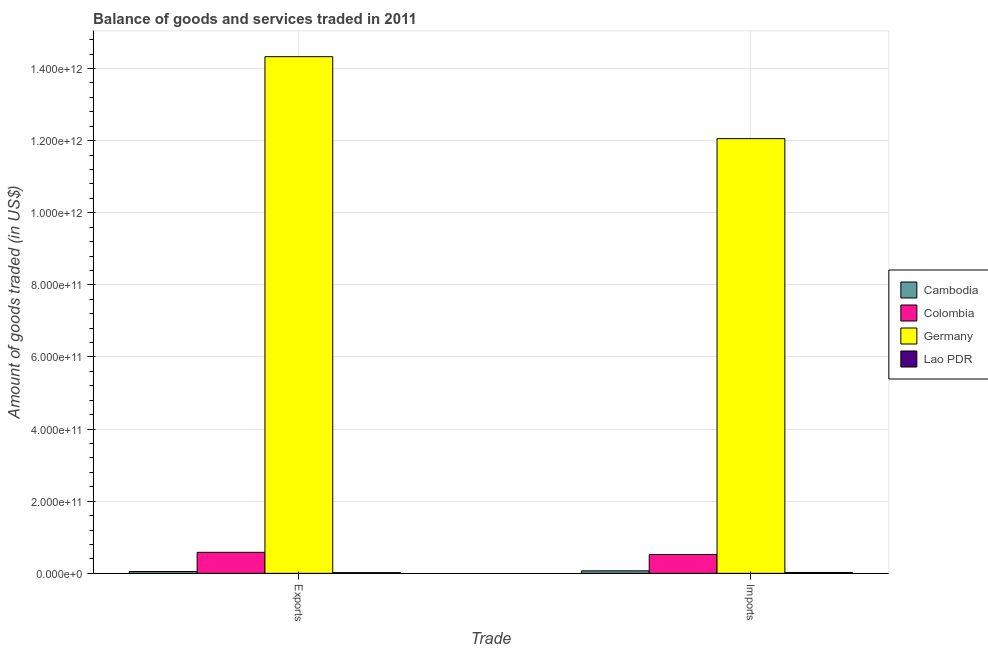How many groups of bars are there?
Give a very brief answer. 2. Are the number of bars per tick equal to the number of legend labels?
Ensure brevity in your answer.  Yes. How many bars are there on the 2nd tick from the left?
Give a very brief answer. 4. What is the label of the 1st group of bars from the left?
Provide a succinct answer. Exports. What is the amount of goods imported in Lao PDR?
Your response must be concise. 2.42e+09. Across all countries, what is the maximum amount of goods imported?
Provide a short and direct response. 1.21e+12. Across all countries, what is the minimum amount of goods exported?
Make the answer very short. 1.85e+09. In which country was the amount of goods exported maximum?
Your response must be concise. Germany. In which country was the amount of goods exported minimum?
Keep it short and to the point. Lao PDR. What is the total amount of goods exported in the graph?
Offer a terse response. 1.50e+12. What is the difference between the amount of goods imported in Germany and that in Colombia?
Give a very brief answer. 1.15e+12. What is the difference between the amount of goods exported in Germany and the amount of goods imported in Colombia?
Give a very brief answer. 1.38e+12. What is the average amount of goods exported per country?
Provide a succinct answer. 3.75e+11. What is the difference between the amount of goods imported and amount of goods exported in Lao PDR?
Your response must be concise. 5.69e+08. What is the ratio of the amount of goods exported in Colombia to that in Germany?
Offer a terse response. 0.04. Is the amount of goods imported in Lao PDR less than that in Colombia?
Make the answer very short. Yes. In how many countries, is the amount of goods imported greater than the average amount of goods imported taken over all countries?
Keep it short and to the point. 1. What does the 3rd bar from the left in Imports represents?
Offer a very short reply. Germany. How many bars are there?
Your answer should be compact. 8. How many countries are there in the graph?
Give a very brief answer. 4. What is the difference between two consecutive major ticks on the Y-axis?
Keep it short and to the point. 2.00e+11. Does the graph contain any zero values?
Offer a terse response. No. Where does the legend appear in the graph?
Provide a succinct answer. Center right. How are the legend labels stacked?
Provide a short and direct response. Vertical. What is the title of the graph?
Offer a very short reply. Balance of goods and services traded in 2011. What is the label or title of the X-axis?
Your answer should be very brief. Trade. What is the label or title of the Y-axis?
Make the answer very short. Amount of goods traded (in US$). What is the Amount of goods traded (in US$) in Cambodia in Exports?
Offer a very short reply. 5.03e+09. What is the Amount of goods traded (in US$) in Colombia in Exports?
Provide a short and direct response. 5.83e+1. What is the Amount of goods traded (in US$) of Germany in Exports?
Give a very brief answer. 1.43e+12. What is the Amount of goods traded (in US$) in Lao PDR in Exports?
Your answer should be very brief. 1.85e+09. What is the Amount of goods traded (in US$) of Cambodia in Imports?
Your answer should be very brief. 6.94e+09. What is the Amount of goods traded (in US$) in Colombia in Imports?
Your answer should be very brief. 5.21e+1. What is the Amount of goods traded (in US$) of Germany in Imports?
Make the answer very short. 1.21e+12. What is the Amount of goods traded (in US$) in Lao PDR in Imports?
Provide a short and direct response. 2.42e+09. Across all Trade, what is the maximum Amount of goods traded (in US$) of Cambodia?
Your answer should be very brief. 6.94e+09. Across all Trade, what is the maximum Amount of goods traded (in US$) of Colombia?
Your response must be concise. 5.83e+1. Across all Trade, what is the maximum Amount of goods traded (in US$) of Germany?
Offer a terse response. 1.43e+12. Across all Trade, what is the maximum Amount of goods traded (in US$) in Lao PDR?
Provide a succinct answer. 2.42e+09. Across all Trade, what is the minimum Amount of goods traded (in US$) of Cambodia?
Keep it short and to the point. 5.03e+09. Across all Trade, what is the minimum Amount of goods traded (in US$) in Colombia?
Give a very brief answer. 5.21e+1. Across all Trade, what is the minimum Amount of goods traded (in US$) of Germany?
Provide a short and direct response. 1.21e+12. Across all Trade, what is the minimum Amount of goods traded (in US$) in Lao PDR?
Make the answer very short. 1.85e+09. What is the total Amount of goods traded (in US$) of Cambodia in the graph?
Give a very brief answer. 1.20e+1. What is the total Amount of goods traded (in US$) of Colombia in the graph?
Give a very brief answer. 1.10e+11. What is the total Amount of goods traded (in US$) in Germany in the graph?
Your answer should be very brief. 2.64e+12. What is the total Amount of goods traded (in US$) of Lao PDR in the graph?
Make the answer very short. 4.28e+09. What is the difference between the Amount of goods traded (in US$) in Cambodia in Exports and that in Imports?
Offer a very short reply. -1.90e+09. What is the difference between the Amount of goods traded (in US$) of Colombia in Exports and that in Imports?
Offer a terse response. 6.14e+09. What is the difference between the Amount of goods traded (in US$) in Germany in Exports and that in Imports?
Provide a succinct answer. 2.27e+11. What is the difference between the Amount of goods traded (in US$) in Lao PDR in Exports and that in Imports?
Keep it short and to the point. -5.69e+08. What is the difference between the Amount of goods traded (in US$) in Cambodia in Exports and the Amount of goods traded (in US$) in Colombia in Imports?
Ensure brevity in your answer.  -4.71e+1. What is the difference between the Amount of goods traded (in US$) in Cambodia in Exports and the Amount of goods traded (in US$) in Germany in Imports?
Make the answer very short. -1.20e+12. What is the difference between the Amount of goods traded (in US$) in Cambodia in Exports and the Amount of goods traded (in US$) in Lao PDR in Imports?
Ensure brevity in your answer.  2.61e+09. What is the difference between the Amount of goods traded (in US$) of Colombia in Exports and the Amount of goods traded (in US$) of Germany in Imports?
Make the answer very short. -1.15e+12. What is the difference between the Amount of goods traded (in US$) of Colombia in Exports and the Amount of goods traded (in US$) of Lao PDR in Imports?
Keep it short and to the point. 5.58e+1. What is the difference between the Amount of goods traded (in US$) in Germany in Exports and the Amount of goods traded (in US$) in Lao PDR in Imports?
Provide a short and direct response. 1.43e+12. What is the average Amount of goods traded (in US$) in Cambodia per Trade?
Offer a terse response. 5.99e+09. What is the average Amount of goods traded (in US$) in Colombia per Trade?
Make the answer very short. 5.52e+1. What is the average Amount of goods traded (in US$) in Germany per Trade?
Provide a short and direct response. 1.32e+12. What is the average Amount of goods traded (in US$) of Lao PDR per Trade?
Give a very brief answer. 2.14e+09. What is the difference between the Amount of goods traded (in US$) in Cambodia and Amount of goods traded (in US$) in Colombia in Exports?
Give a very brief answer. -5.32e+1. What is the difference between the Amount of goods traded (in US$) of Cambodia and Amount of goods traded (in US$) of Germany in Exports?
Make the answer very short. -1.43e+12. What is the difference between the Amount of goods traded (in US$) of Cambodia and Amount of goods traded (in US$) of Lao PDR in Exports?
Offer a terse response. 3.18e+09. What is the difference between the Amount of goods traded (in US$) of Colombia and Amount of goods traded (in US$) of Germany in Exports?
Give a very brief answer. -1.37e+12. What is the difference between the Amount of goods traded (in US$) in Colombia and Amount of goods traded (in US$) in Lao PDR in Exports?
Make the answer very short. 5.64e+1. What is the difference between the Amount of goods traded (in US$) of Germany and Amount of goods traded (in US$) of Lao PDR in Exports?
Your response must be concise. 1.43e+12. What is the difference between the Amount of goods traded (in US$) in Cambodia and Amount of goods traded (in US$) in Colombia in Imports?
Offer a terse response. -4.52e+1. What is the difference between the Amount of goods traded (in US$) in Cambodia and Amount of goods traded (in US$) in Germany in Imports?
Offer a very short reply. -1.20e+12. What is the difference between the Amount of goods traded (in US$) in Cambodia and Amount of goods traded (in US$) in Lao PDR in Imports?
Provide a short and direct response. 4.51e+09. What is the difference between the Amount of goods traded (in US$) in Colombia and Amount of goods traded (in US$) in Germany in Imports?
Offer a terse response. -1.15e+12. What is the difference between the Amount of goods traded (in US$) of Colombia and Amount of goods traded (in US$) of Lao PDR in Imports?
Provide a succinct answer. 4.97e+1. What is the difference between the Amount of goods traded (in US$) of Germany and Amount of goods traded (in US$) of Lao PDR in Imports?
Offer a terse response. 1.20e+12. What is the ratio of the Amount of goods traded (in US$) in Cambodia in Exports to that in Imports?
Ensure brevity in your answer.  0.73. What is the ratio of the Amount of goods traded (in US$) of Colombia in Exports to that in Imports?
Your answer should be compact. 1.12. What is the ratio of the Amount of goods traded (in US$) in Germany in Exports to that in Imports?
Make the answer very short. 1.19. What is the ratio of the Amount of goods traded (in US$) of Lao PDR in Exports to that in Imports?
Make the answer very short. 0.77. What is the difference between the highest and the second highest Amount of goods traded (in US$) of Cambodia?
Provide a short and direct response. 1.90e+09. What is the difference between the highest and the second highest Amount of goods traded (in US$) of Colombia?
Provide a succinct answer. 6.14e+09. What is the difference between the highest and the second highest Amount of goods traded (in US$) of Germany?
Provide a succinct answer. 2.27e+11. What is the difference between the highest and the second highest Amount of goods traded (in US$) in Lao PDR?
Make the answer very short. 5.69e+08. What is the difference between the highest and the lowest Amount of goods traded (in US$) in Cambodia?
Your answer should be very brief. 1.90e+09. What is the difference between the highest and the lowest Amount of goods traded (in US$) of Colombia?
Offer a terse response. 6.14e+09. What is the difference between the highest and the lowest Amount of goods traded (in US$) of Germany?
Provide a succinct answer. 2.27e+11. What is the difference between the highest and the lowest Amount of goods traded (in US$) of Lao PDR?
Provide a succinct answer. 5.69e+08. 